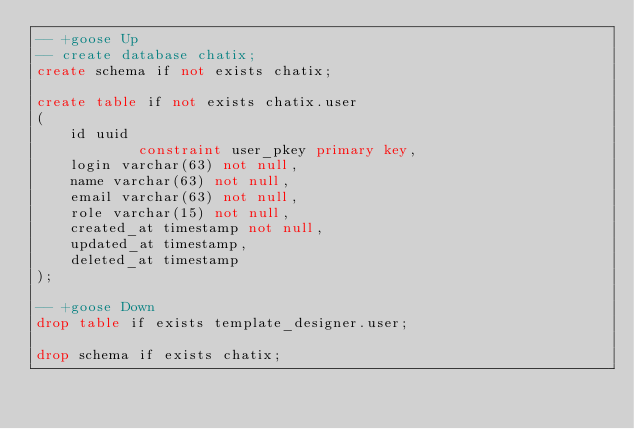<code> <loc_0><loc_0><loc_500><loc_500><_SQL_>-- +goose Up
-- create database chatix;
create schema if not exists chatix;

create table if not exists chatix.user
(
    id uuid
            constraint user_pkey primary key,
    login varchar(63) not null,
    name varchar(63) not null,
    email varchar(63) not null,
    role varchar(15) not null,
    created_at timestamp not null,
    updated_at timestamp,
    deleted_at timestamp
);

-- +goose Down
drop table if exists template_designer.user;

drop schema if exists chatix;
</code> 